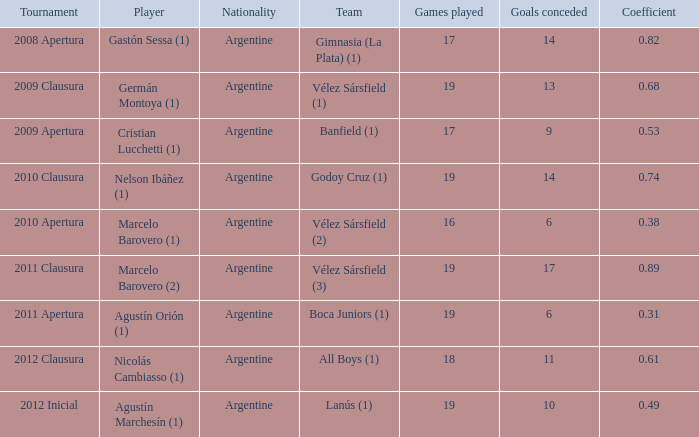Can you tell me about the 2010 clausura competition? 0.74. 